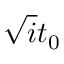Convert formula to latex. <formula><loc_0><loc_0><loc_500><loc_500>\sqrt { i } t _ { 0 }</formula> 